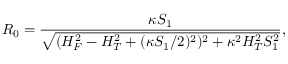<formula> <loc_0><loc_0><loc_500><loc_500>R _ { 0 } = { \frac { \kappa S _ { 1 } } { \sqrt { ( H _ { F } ^ { 2 } - H _ { T } ^ { 2 } + ( \kappa S _ { 1 } / 2 ) ^ { 2 } ) ^ { 2 } + \kappa ^ { 2 } H _ { T } ^ { 2 } S _ { 1 } ^ { 2 } } } } ,</formula> 